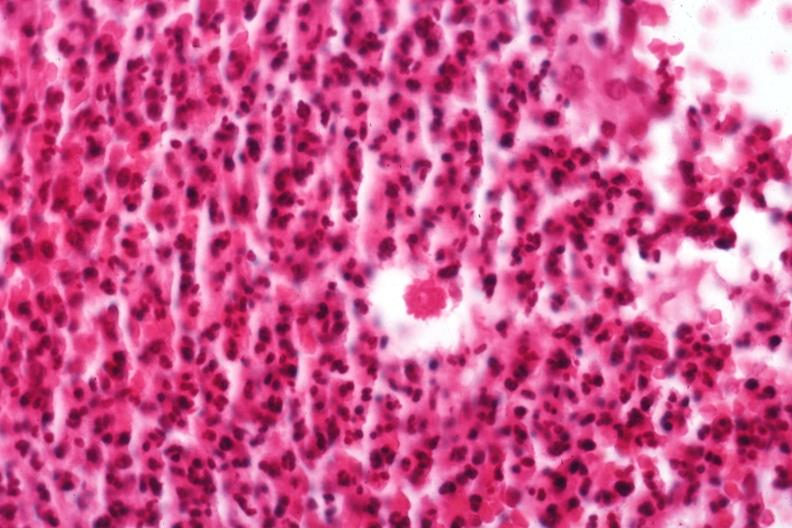what does this image show?
Answer the question using a single word or phrase. Organism 